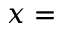<formula> <loc_0><loc_0><loc_500><loc_500>x =</formula> 